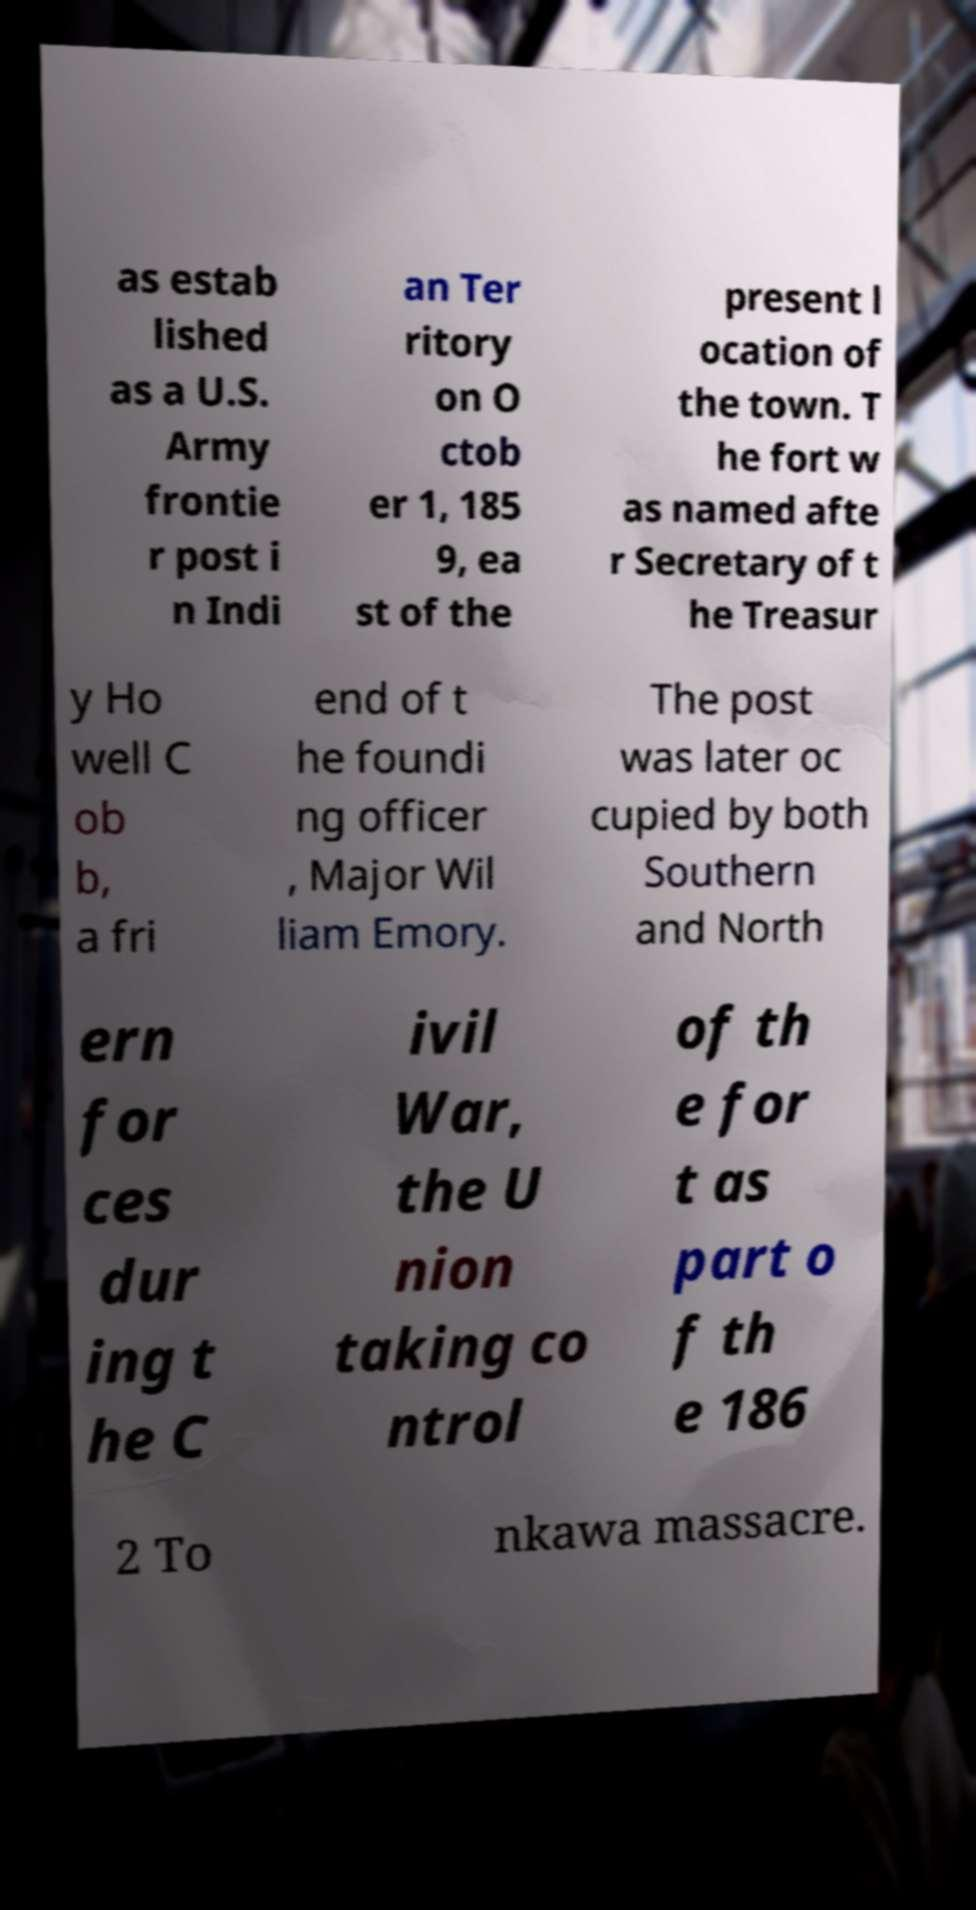Can you accurately transcribe the text from the provided image for me? as estab lished as a U.S. Army frontie r post i n Indi an Ter ritory on O ctob er 1, 185 9, ea st of the present l ocation of the town. T he fort w as named afte r Secretary of t he Treasur y Ho well C ob b, a fri end of t he foundi ng officer , Major Wil liam Emory. The post was later oc cupied by both Southern and North ern for ces dur ing t he C ivil War, the U nion taking co ntrol of th e for t as part o f th e 186 2 To nkawa massacre. 